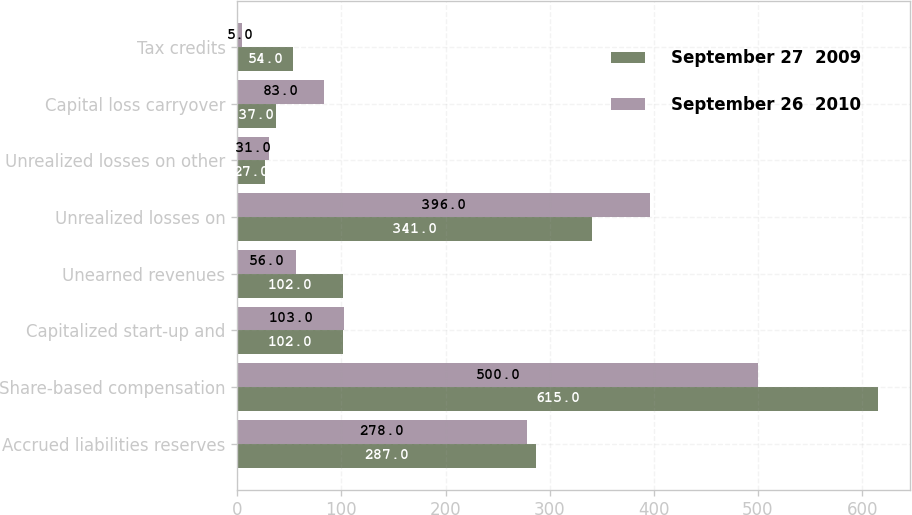Convert chart to OTSL. <chart><loc_0><loc_0><loc_500><loc_500><stacked_bar_chart><ecel><fcel>Accrued liabilities reserves<fcel>Share-based compensation<fcel>Capitalized start-up and<fcel>Unearned revenues<fcel>Unrealized losses on<fcel>Unrealized losses on other<fcel>Capital loss carryover<fcel>Tax credits<nl><fcel>September 27  2009<fcel>287<fcel>615<fcel>102<fcel>102<fcel>341<fcel>27<fcel>37<fcel>54<nl><fcel>September 26  2010<fcel>278<fcel>500<fcel>103<fcel>56<fcel>396<fcel>31<fcel>83<fcel>5<nl></chart> 